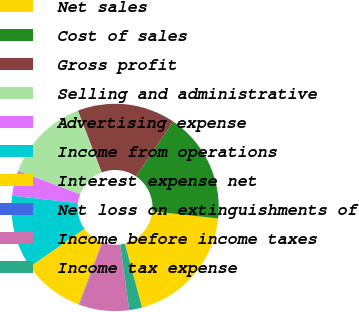Convert chart to OTSL. <chart><loc_0><loc_0><loc_500><loc_500><pie_chart><fcel>Net sales<fcel>Cost of sales<fcel>Gross profit<fcel>Selling and administrative<fcel>Advertising expense<fcel>Income from operations<fcel>Interest expense net<fcel>Net loss on extinguishments of<fcel>Income before income taxes<fcel>Income tax expense<nl><fcel>19.12%<fcel>17.22%<fcel>15.32%<fcel>13.42%<fcel>3.92%<fcel>11.52%<fcel>9.62%<fcel>0.11%<fcel>7.72%<fcel>2.02%<nl></chart> 